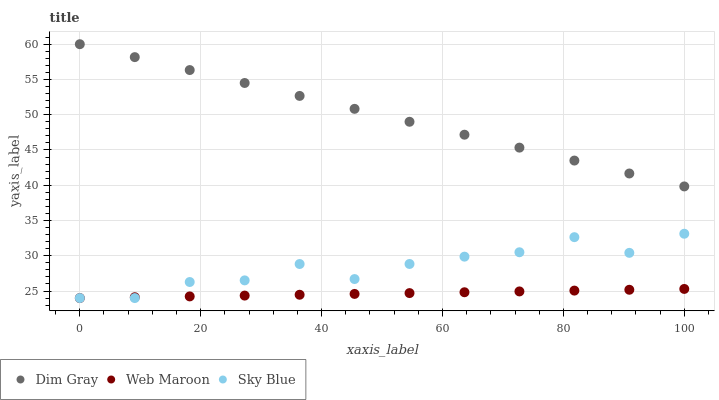Does Web Maroon have the minimum area under the curve?
Answer yes or no. Yes. Does Dim Gray have the maximum area under the curve?
Answer yes or no. Yes. Does Dim Gray have the minimum area under the curve?
Answer yes or no. No. Does Web Maroon have the maximum area under the curve?
Answer yes or no. No. Is Web Maroon the smoothest?
Answer yes or no. Yes. Is Sky Blue the roughest?
Answer yes or no. Yes. Is Dim Gray the smoothest?
Answer yes or no. No. Is Dim Gray the roughest?
Answer yes or no. No. Does Sky Blue have the lowest value?
Answer yes or no. Yes. Does Dim Gray have the lowest value?
Answer yes or no. No. Does Dim Gray have the highest value?
Answer yes or no. Yes. Does Web Maroon have the highest value?
Answer yes or no. No. Is Sky Blue less than Dim Gray?
Answer yes or no. Yes. Is Dim Gray greater than Web Maroon?
Answer yes or no. Yes. Does Web Maroon intersect Sky Blue?
Answer yes or no. Yes. Is Web Maroon less than Sky Blue?
Answer yes or no. No. Is Web Maroon greater than Sky Blue?
Answer yes or no. No. Does Sky Blue intersect Dim Gray?
Answer yes or no. No. 